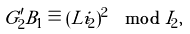Convert formula to latex. <formula><loc_0><loc_0><loc_500><loc_500>G ^ { \prime } _ { 2 } B _ { 1 } \equiv ( L i _ { 2 } ) ^ { 2 } \mod I _ { 2 } ,</formula> 